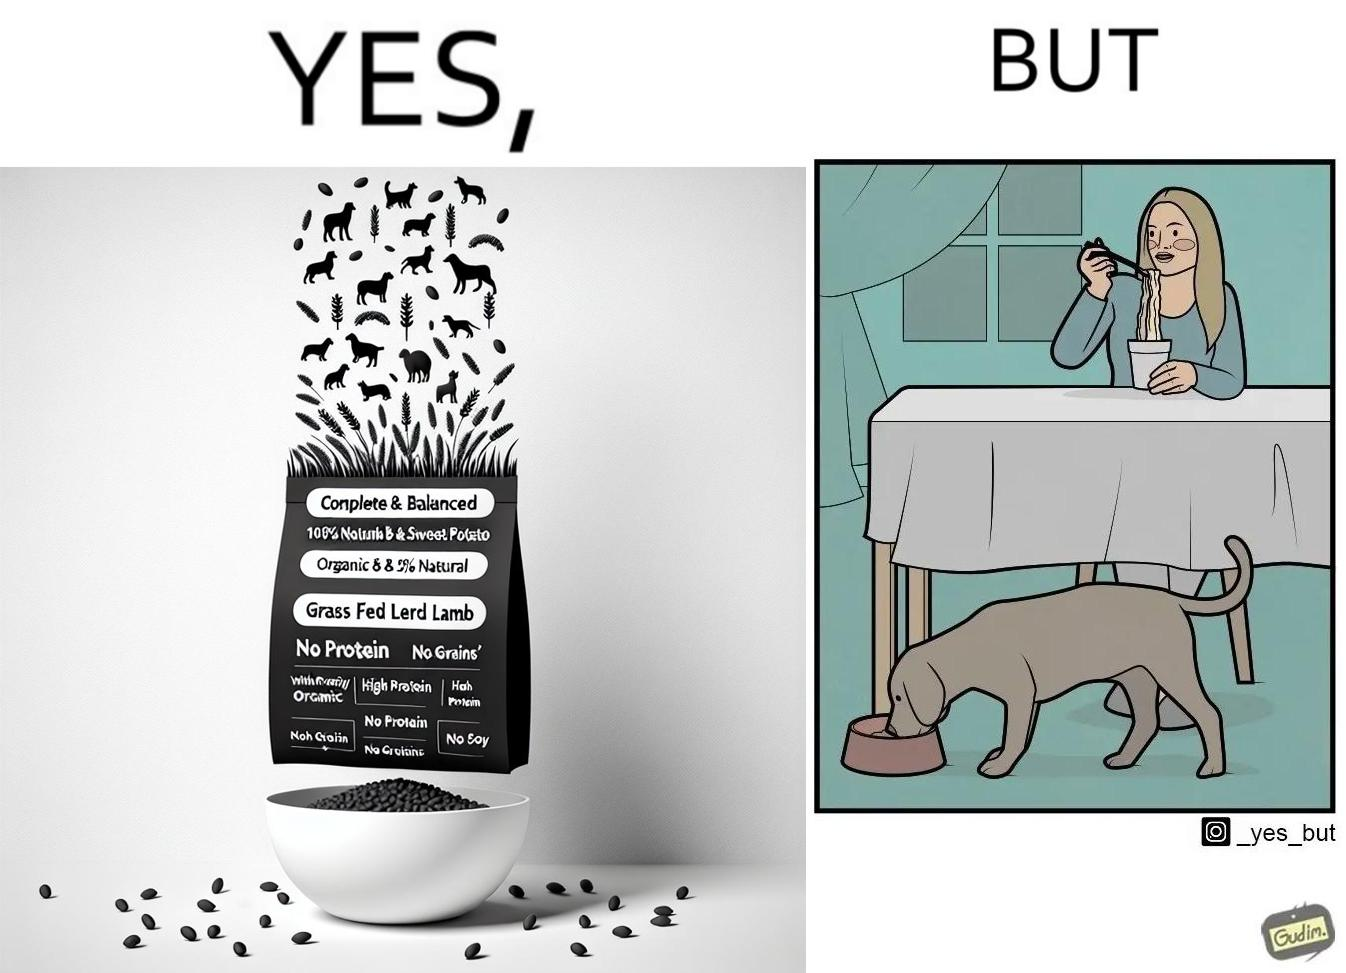What do you see in each half of this image? In the left part of the image: The image shows food grains being poured into a bowl from the packet. The packet says "Complete & Balanced", "Organic", "100% Natural", "Grass Fed Lamb & Sweet Potato" , "With Prebiotic", "High Protein", "No grains", "No Gluten" and "No Soy". In the right part of the image: The image shows a dog eating food from its bowl on the floor and a woman eating noodles from a cup on the table. 